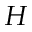Convert formula to latex. <formula><loc_0><loc_0><loc_500><loc_500>H</formula> 